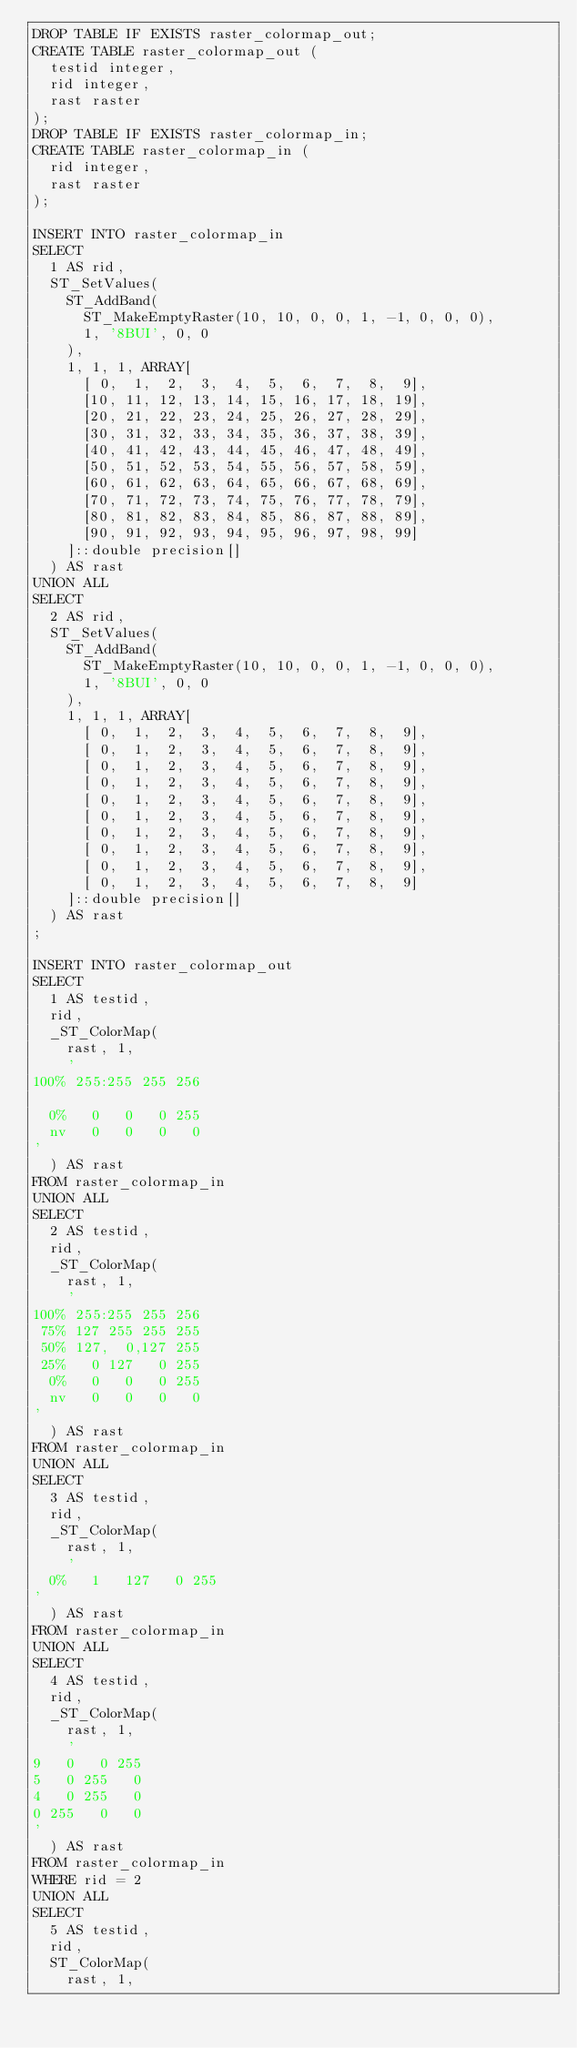Convert code to text. <code><loc_0><loc_0><loc_500><loc_500><_SQL_>DROP TABLE IF EXISTS raster_colormap_out;
CREATE TABLE raster_colormap_out (
	testid integer,
	rid integer,
	rast raster
);
DROP TABLE IF EXISTS raster_colormap_in;
CREATE TABLE raster_colormap_in (
	rid integer,
	rast raster
);

INSERT INTO raster_colormap_in
SELECT
	1 AS rid,
	ST_SetValues(
		ST_AddBand(
			ST_MakeEmptyRaster(10, 10, 0, 0, 1, -1, 0, 0, 0),
			1, '8BUI', 0, 0
		),
		1, 1, 1, ARRAY[
			[ 0,  1,  2,  3,  4,  5,  6,  7,  8,  9],
			[10, 11, 12, 13, 14, 15, 16, 17, 18, 19],
			[20, 21, 22, 23, 24, 25, 26, 27, 28, 29],
			[30, 31, 32, 33, 34, 35, 36, 37, 38, 39],
			[40, 41, 42, 43, 44, 45, 46, 47, 48, 49],
			[50, 51, 52, 53, 54, 55, 56, 57, 58, 59],
			[60, 61, 62, 63, 64, 65, 66, 67, 68, 69],
			[70, 71, 72, 73, 74, 75, 76, 77, 78, 79],
			[80, 81, 82, 83, 84, 85, 86, 87, 88, 89],
			[90, 91, 92, 93, 94, 95, 96, 97, 98, 99]
		]::double precision[]
	) AS rast
UNION ALL
SELECT
	2 AS rid,
	ST_SetValues(
		ST_AddBand(
			ST_MakeEmptyRaster(10, 10, 0, 0, 1, -1, 0, 0, 0),
			1, '8BUI', 0, 0
		),
		1, 1, 1, ARRAY[
			[ 0,  1,  2,  3,  4,  5,  6,  7,  8,  9],
			[ 0,  1,  2,  3,  4,  5,  6,  7,  8,  9],
			[ 0,  1,  2,  3,  4,  5,  6,  7,  8,  9],
			[ 0,  1,  2,  3,  4,  5,  6,  7,  8,  9],
			[ 0,  1,  2,  3,  4,  5,  6,  7,  8,  9],
			[ 0,  1,  2,  3,  4,  5,  6,  7,  8,  9],
			[ 0,  1,  2,  3,  4,  5,  6,  7,  8,  9],
			[ 0,  1,  2,  3,  4,  5,  6,  7,  8,  9],
			[ 0,  1,  2,  3,  4,  5,  6,  7,  8,  9],
			[ 0,  1,  2,  3,  4,  5,  6,  7,  8,  9]
		]::double precision[]
	) AS rast
;

INSERT INTO raster_colormap_out
SELECT
	1 AS testid,
	rid,
	_ST_ColorMap(
		rast, 1,
		'
100% 255:255 255 256

  0%   0   0   0 255
  nv   0   0   0   0
'
	) AS rast
FROM raster_colormap_in
UNION ALL
SELECT
	2 AS testid,
	rid,
	_ST_ColorMap(
		rast, 1,
		'
100% 255:255 255 256
 75% 127 255 255 255
 50% 127,  0,127 255
 25%   0 127   0 255
  0%   0   0   0 255
  nv   0   0   0   0
'
	) AS rast
FROM raster_colormap_in
UNION ALL
SELECT
	3 AS testid,
	rid,
	_ST_ColorMap(
		rast, 1,
		'
  0%   1   127   0 255
'
	) AS rast
FROM raster_colormap_in
UNION ALL
SELECT
	4 AS testid,
	rid,
	_ST_ColorMap(
		rast, 1,
		'
9   0   0 255
5   0 255   0
4   0 255   0
0 255   0   0
'
	) AS rast
FROM raster_colormap_in
WHERE rid = 2
UNION ALL
SELECT
	5 AS testid,
	rid,
	ST_ColorMap(
		rast, 1,</code> 